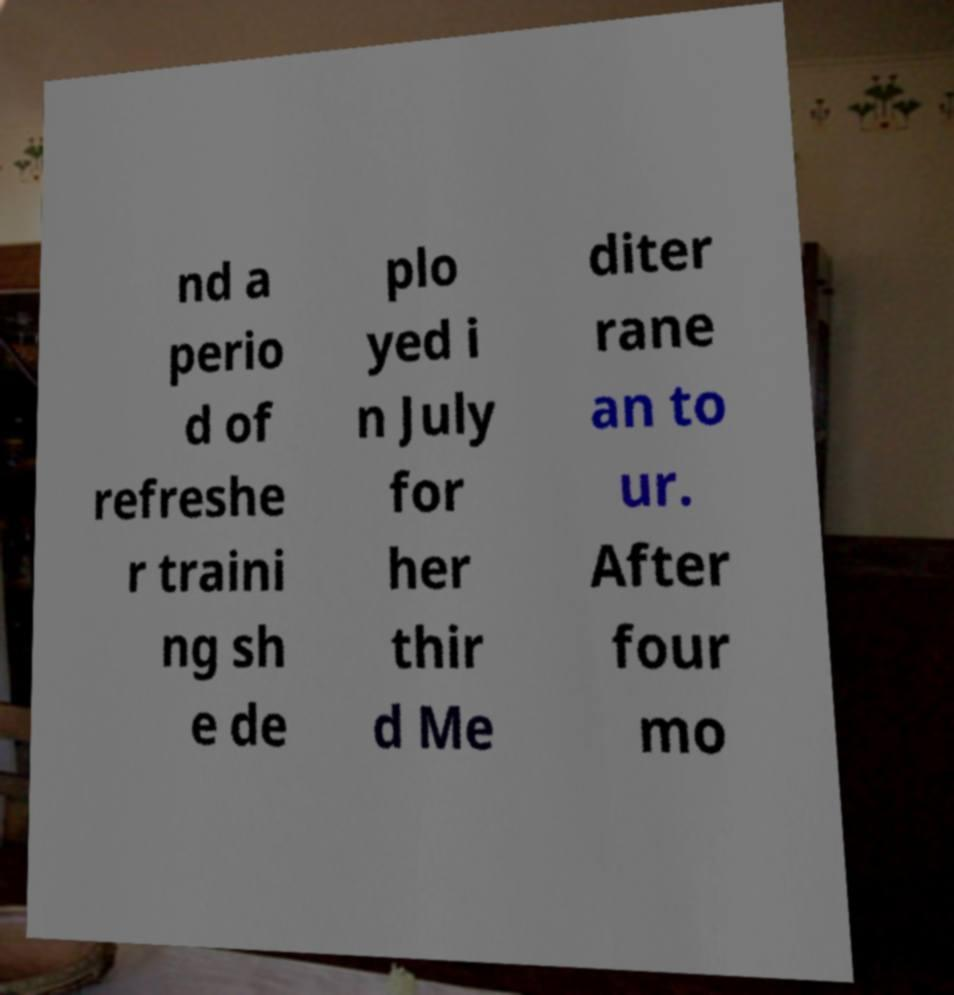Please read and relay the text visible in this image. What does it say? nd a perio d of refreshe r traini ng sh e de plo yed i n July for her thir d Me diter rane an to ur. After four mo 